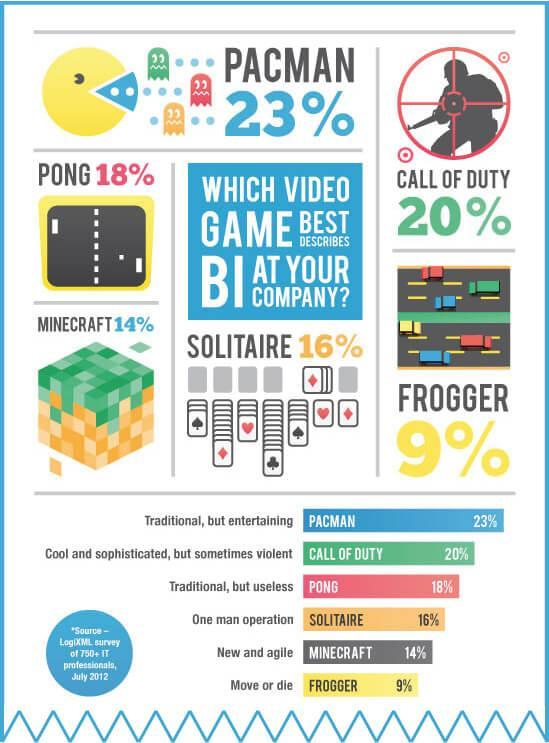which game has a shooter
Answer the question with a short phrase. call of duty which game has cards solitaire how many vehicles are shown in frogger 6 